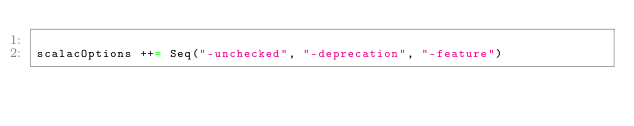Convert code to text. <code><loc_0><loc_0><loc_500><loc_500><_Scala_>
scalacOptions ++= Seq("-unchecked", "-deprecation", "-feature")
</code> 